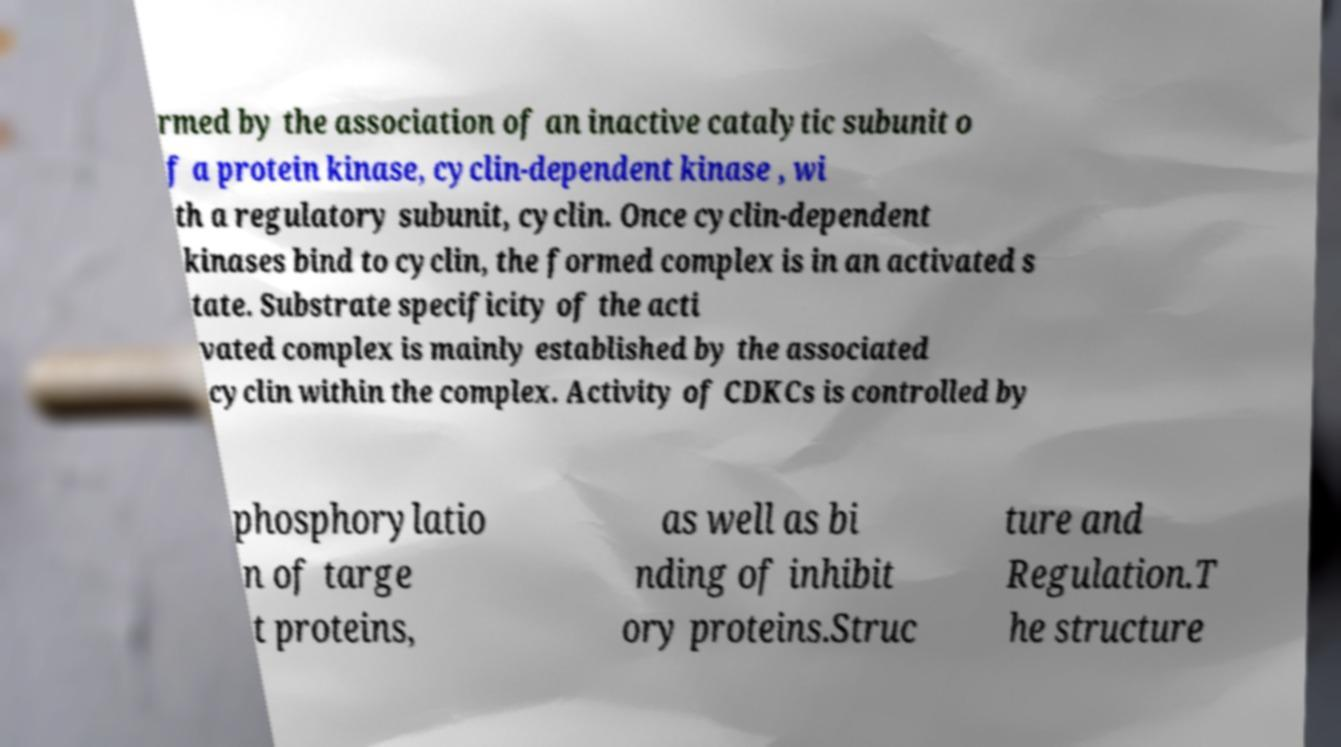Please identify and transcribe the text found in this image. rmed by the association of an inactive catalytic subunit o f a protein kinase, cyclin-dependent kinase , wi th a regulatory subunit, cyclin. Once cyclin-dependent kinases bind to cyclin, the formed complex is in an activated s tate. Substrate specificity of the acti vated complex is mainly established by the associated cyclin within the complex. Activity of CDKCs is controlled by phosphorylatio n of targe t proteins, as well as bi nding of inhibit ory proteins.Struc ture and Regulation.T he structure 